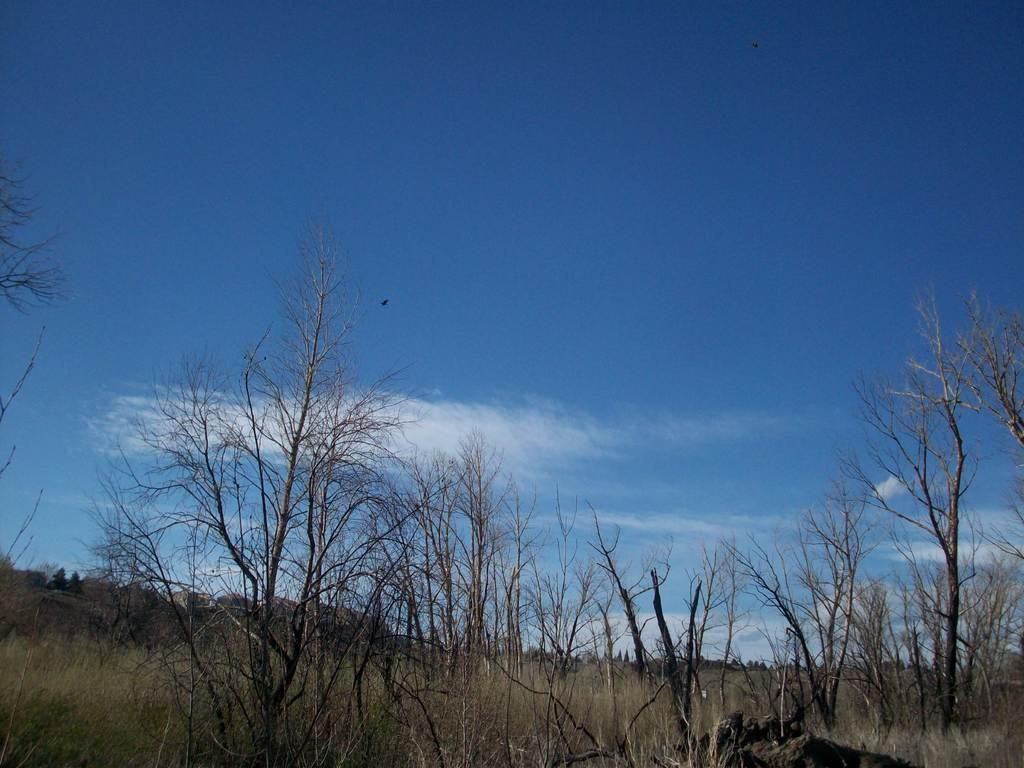What type of vegetation is present in the image? There are trees and plants in the image. Where are the trees and plants located in relation to the image? The trees and plants are in the foreground of the image. What can be seen in the background of the image? The sky is visible in the background of the image. What is the condition of the sky in the image? The sky is clear in the image. How many pigs are visible in the image? There are no pigs present in the image; it features trees and plants in the foreground and a clear sky in the background. Can you tell me which guide is leading the group of trees in the image? There is no group of trees being led by a guide in the image; it simply shows trees and plants in the foreground and a clear sky in the background. 